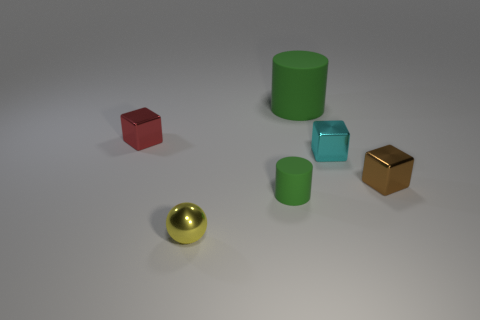Are the small green object and the cylinder behind the red object made of the same material?
Keep it short and to the point. Yes. What is the size of the red thing that is the same shape as the brown thing?
Make the answer very short. Small. What is the yellow sphere made of?
Your answer should be very brief. Metal. There is a object behind the small block that is left of the small object that is in front of the small green rubber cylinder; what is its material?
Ensure brevity in your answer.  Rubber. Does the metal thing that is left of the tiny shiny sphere have the same size as the green rubber object that is in front of the big object?
Your answer should be very brief. Yes. How many other objects are there of the same material as the yellow ball?
Ensure brevity in your answer.  3. What number of metal objects are tiny yellow objects or small brown objects?
Provide a short and direct response. 2. Are there fewer tiny brown metallic things than purple shiny spheres?
Provide a short and direct response. No. Do the metal sphere and the metallic thing on the left side of the yellow metal thing have the same size?
Your answer should be very brief. Yes. Is there anything else that has the same shape as the yellow thing?
Give a very brief answer. No. 